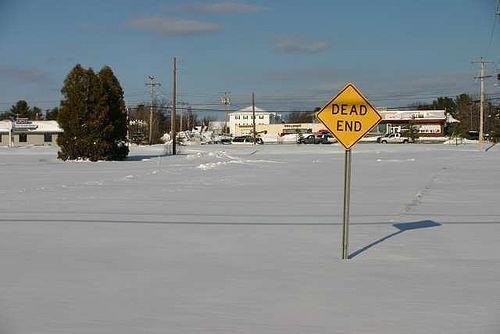How many people are pulling luggage?
Give a very brief answer. 0. 